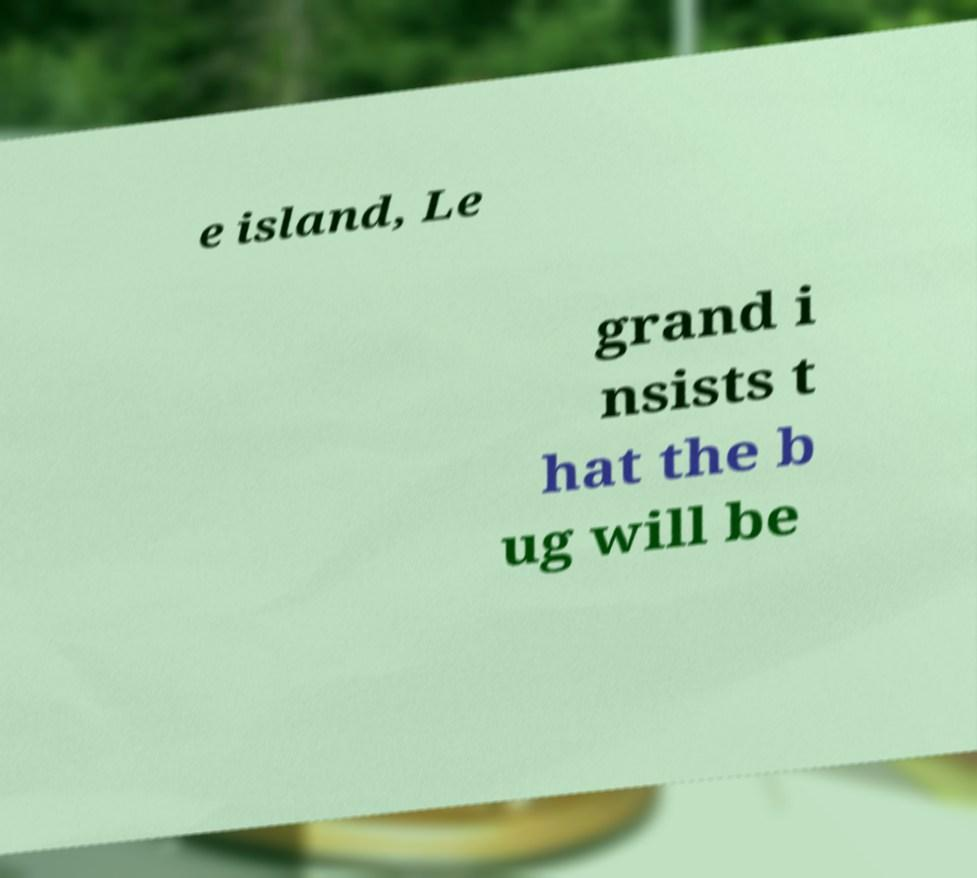Please read and relay the text visible in this image. What does it say? e island, Le grand i nsists t hat the b ug will be 